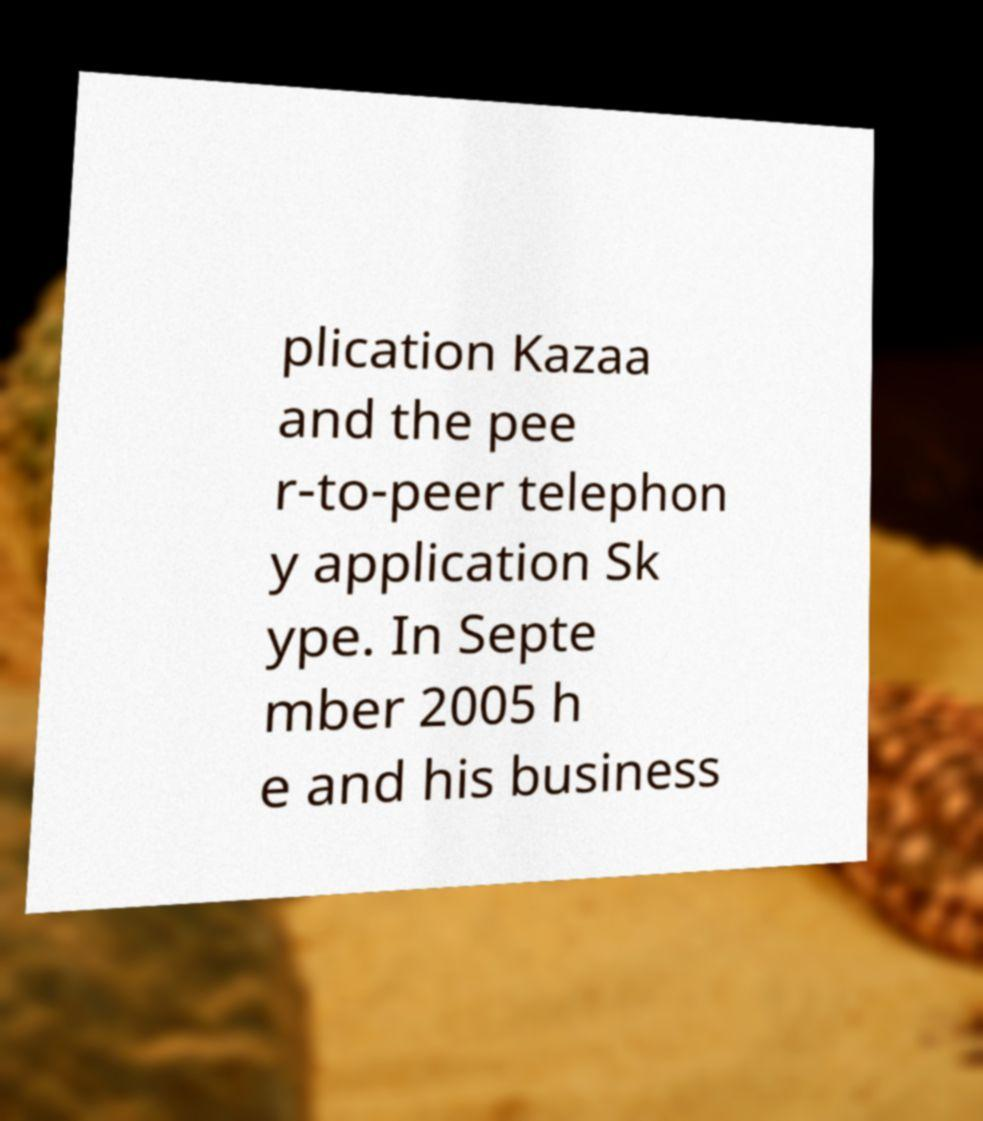Could you extract and type out the text from this image? plication Kazaa and the pee r-to-peer telephon y application Sk ype. In Septe mber 2005 h e and his business 